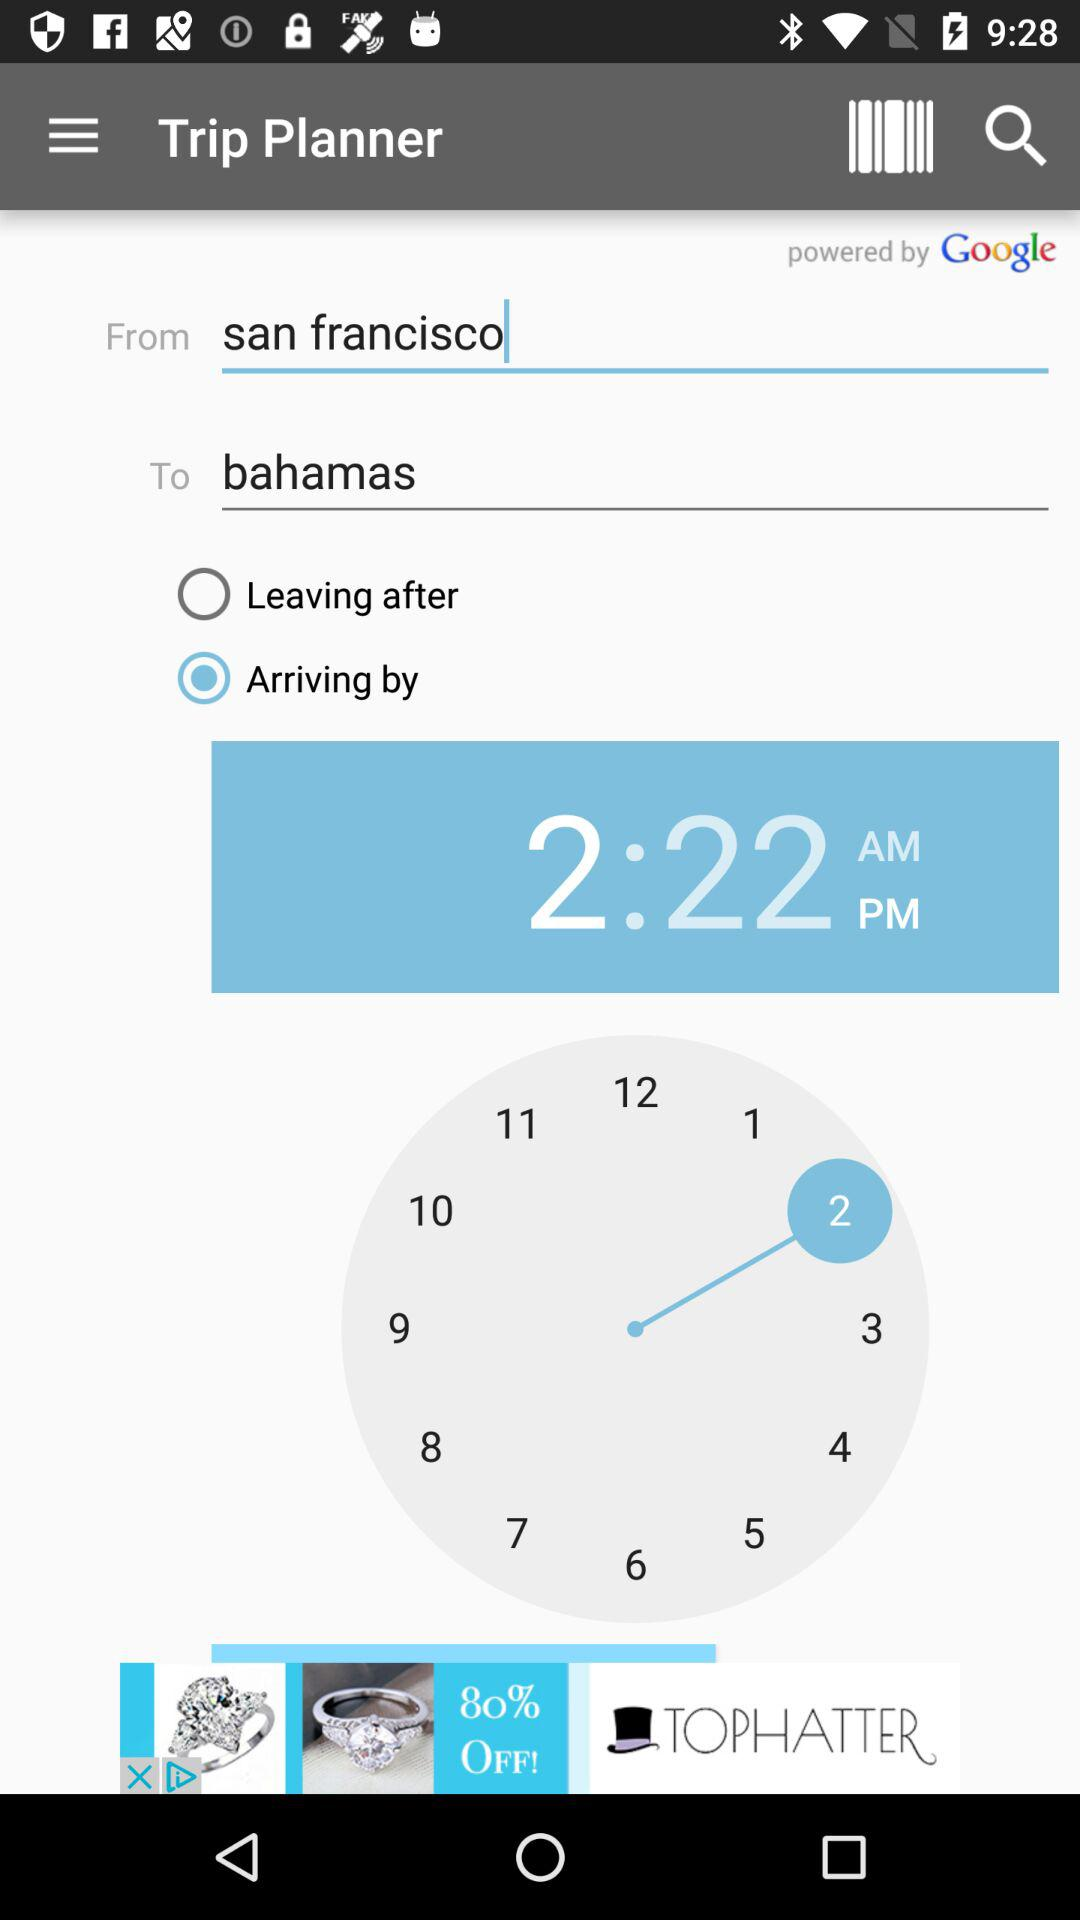What is the status of the "Arriving by"? The status is "on". 